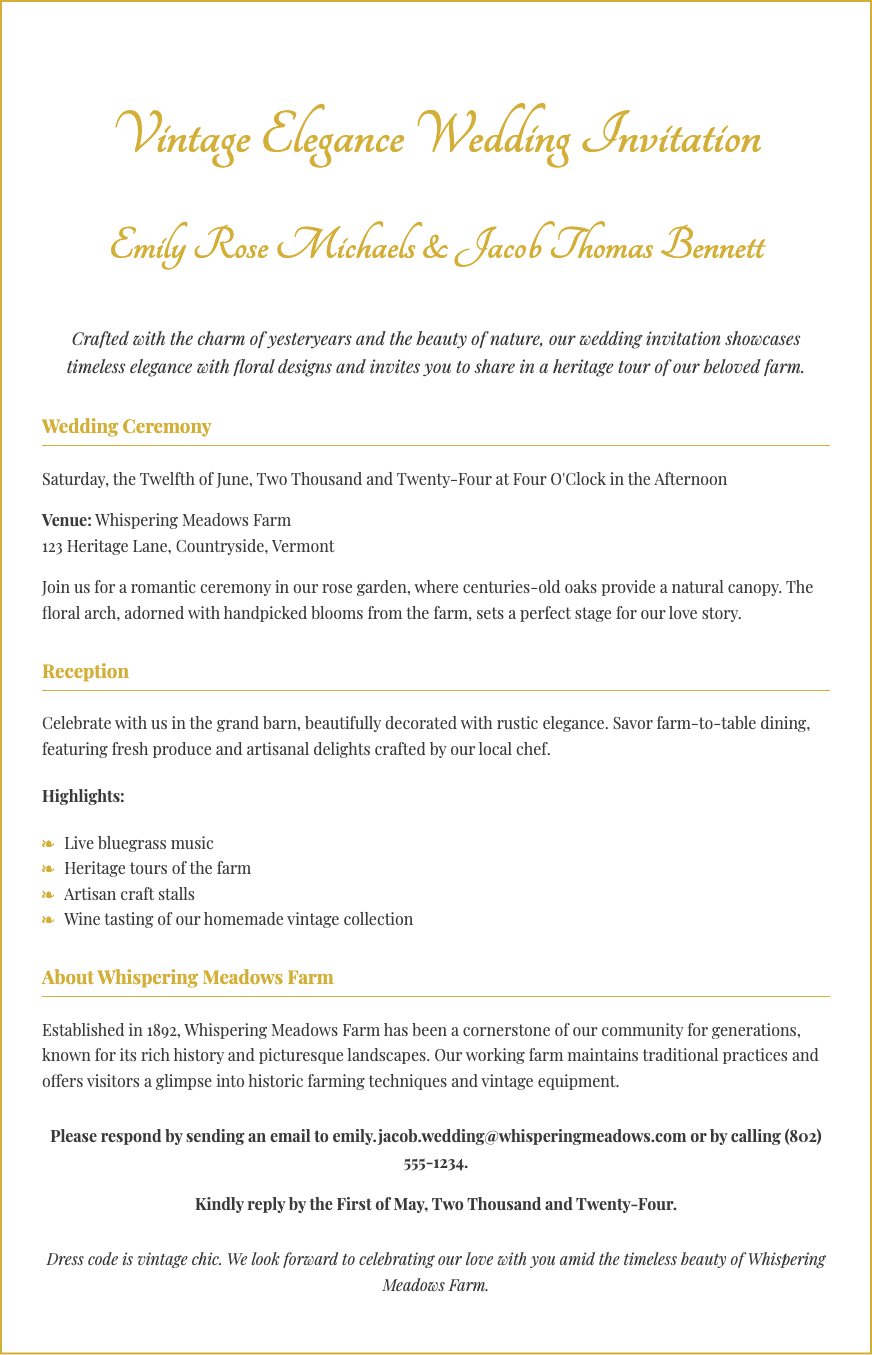What is the date of the wedding ceremony? The wedding ceremony is scheduled for Saturday, the Twelfth of June, Two Thousand and Twenty-Four.
Answer: June 12, 2024 What is the email address for RSVPs? The document provides an email address for RSVPs: emily.jacob.wedding@whisperingmeadows.com.
Answer: emily.jacob.wedding@whisperingmeadows.com What is the name of the bride? The bride's name is Emily Rose Michaels, as stated in the invitation.
Answer: Emily Rose Michaels What type of music will be featured at the reception? The document mentions that live bluegrass music will be performed at the reception.
Answer: Live bluegrass music How many years has Whispering Meadows Farm been established? The farm was established in 1892, and the wedding is in 2024, making it 132 years old.
Answer: 132 years What is the dress code for the wedding? The dress code specified in the additional notes is vintage chic.
Answer: Vintage chic What type of dining will be offered at the reception? The invitation describes the dining at the reception as farm-to-table dining.
Answer: Farm-to-table dining Where is the wedding venue located? The venue is located at 123 Heritage Lane, Countryside, Vermont.
Answer: 123 Heritage Lane, Countryside, Vermont 